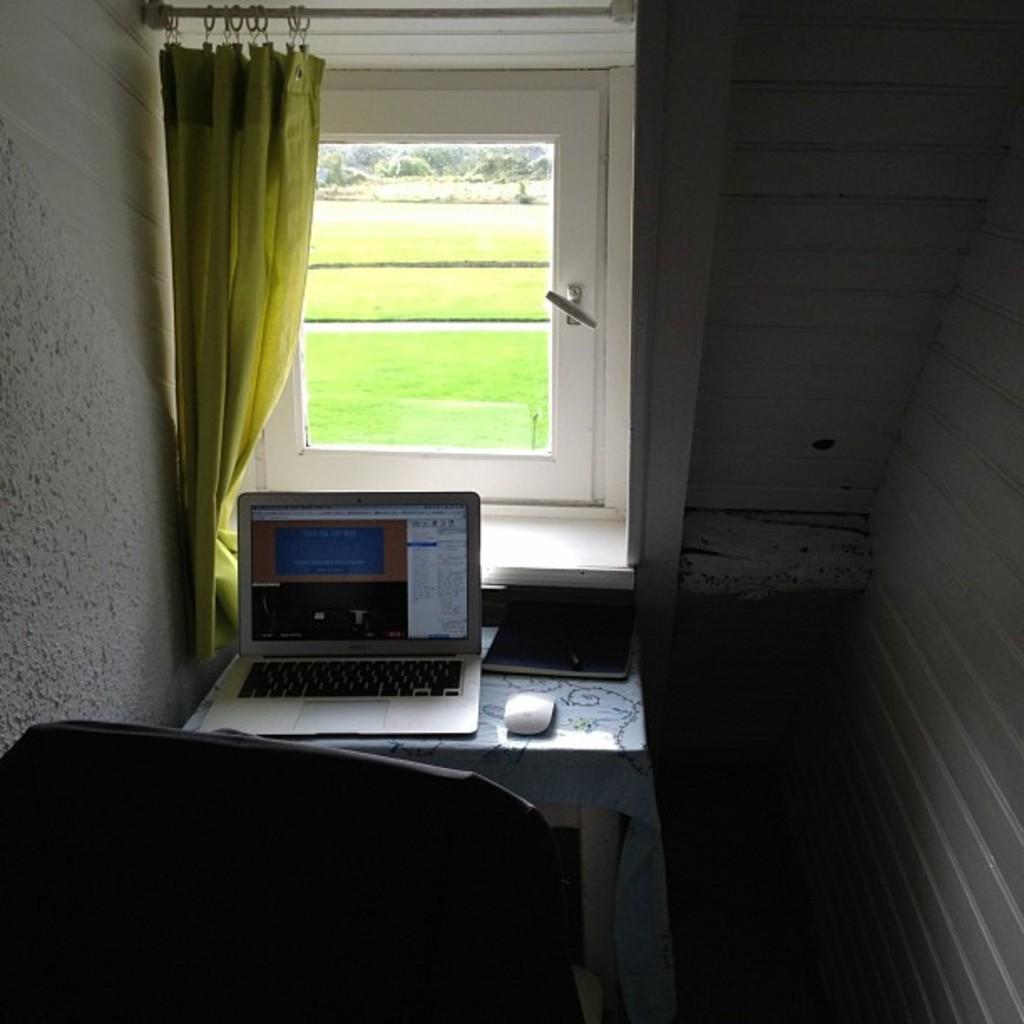How would you summarize this image in a sentence or two? This is a picture in a room, in the room there is a table on the table there is a laptop and the mouse and chair. Backside of the system there is a window through window we can see the grass. 